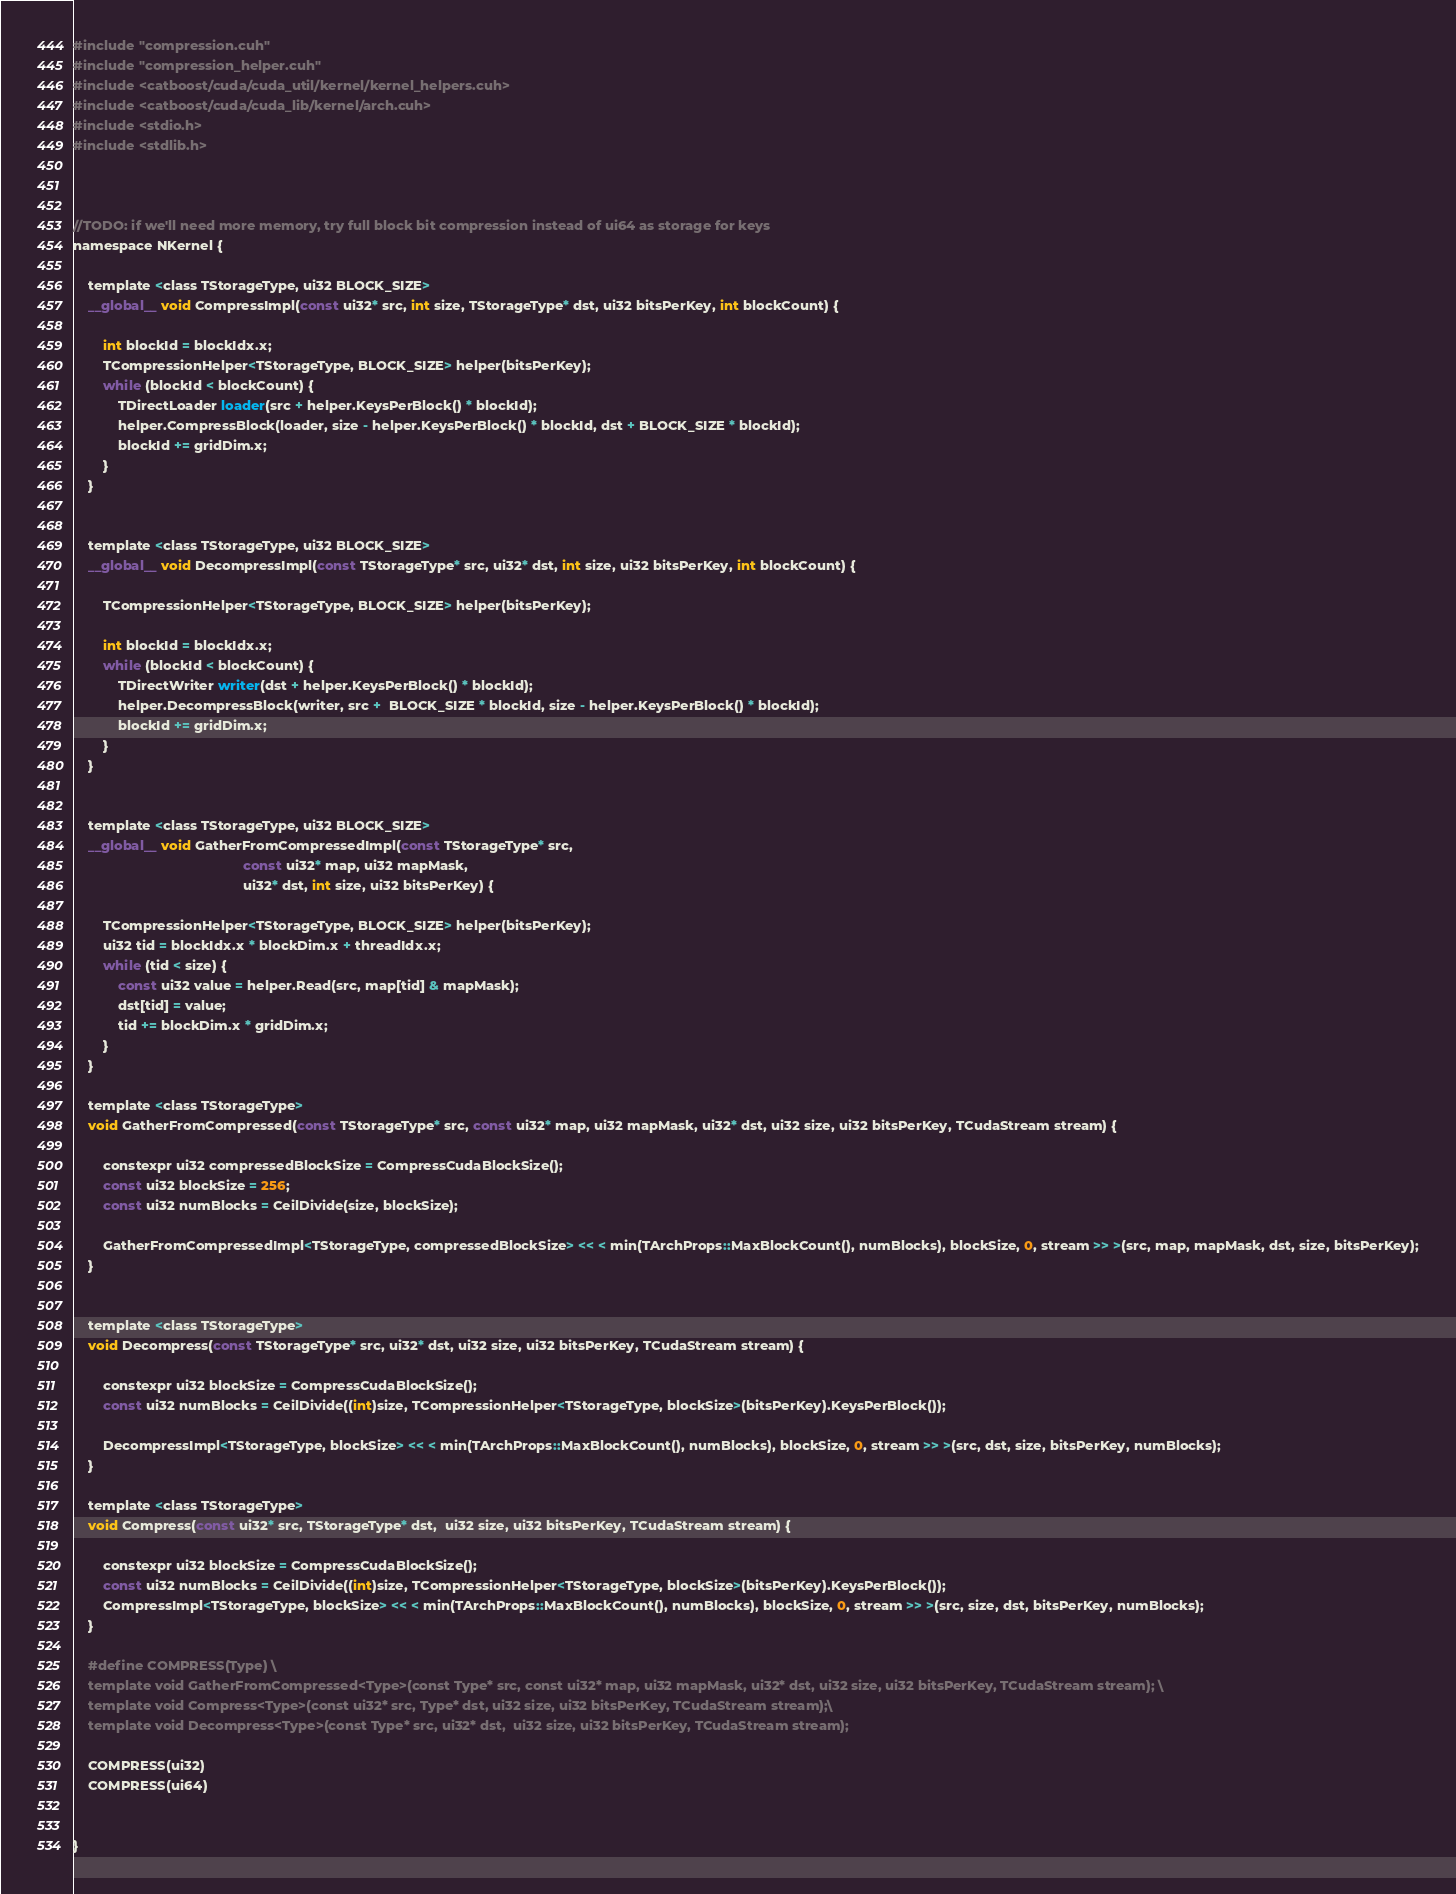Convert code to text. <code><loc_0><loc_0><loc_500><loc_500><_Cuda_>#include "compression.cuh"
#include "compression_helper.cuh"
#include <catboost/cuda/cuda_util/kernel/kernel_helpers.cuh>
#include <catboost/cuda/cuda_lib/kernel/arch.cuh>
#include <stdio.h>
#include <stdlib.h>



//TODO: if we'll need more memory, try full block bit compression instead of ui64 as storage for keys
namespace NKernel {

    template <class TStorageType, ui32 BLOCK_SIZE>
    __global__ void CompressImpl(const ui32* src, int size, TStorageType* dst, ui32 bitsPerKey, int blockCount) {

        int blockId = blockIdx.x;
        TCompressionHelper<TStorageType, BLOCK_SIZE> helper(bitsPerKey);
        while (blockId < blockCount) {
            TDirectLoader loader(src + helper.KeysPerBlock() * blockId);
            helper.CompressBlock(loader, size - helper.KeysPerBlock() * blockId, dst + BLOCK_SIZE * blockId);
            blockId += gridDim.x;
        }
    }


    template <class TStorageType, ui32 BLOCK_SIZE>
    __global__ void DecompressImpl(const TStorageType* src, ui32* dst, int size, ui32 bitsPerKey, int blockCount) {

        TCompressionHelper<TStorageType, BLOCK_SIZE> helper(bitsPerKey);

        int blockId = blockIdx.x;
        while (blockId < blockCount) {
            TDirectWriter writer(dst + helper.KeysPerBlock() * blockId);
            helper.DecompressBlock(writer, src +  BLOCK_SIZE * blockId, size - helper.KeysPerBlock() * blockId);
            blockId += gridDim.x;
        }
    }


    template <class TStorageType, ui32 BLOCK_SIZE>
    __global__ void GatherFromCompressedImpl(const TStorageType* src,
                                             const ui32* map, ui32 mapMask,
                                             ui32* dst, int size, ui32 bitsPerKey) {

        TCompressionHelper<TStorageType, BLOCK_SIZE> helper(bitsPerKey);
        ui32 tid = blockIdx.x * blockDim.x + threadIdx.x;
        while (tid < size) {
            const ui32 value = helper.Read(src, map[tid] & mapMask);
            dst[tid] = value;
            tid += blockDim.x * gridDim.x;
        }
    }

    template <class TStorageType>
    void GatherFromCompressed(const TStorageType* src, const ui32* map, ui32 mapMask, ui32* dst, ui32 size, ui32 bitsPerKey, TCudaStream stream) {

        constexpr ui32 compressedBlockSize = CompressCudaBlockSize();
        const ui32 blockSize = 256;
        const ui32 numBlocks = CeilDivide(size, blockSize);

        GatherFromCompressedImpl<TStorageType, compressedBlockSize> << < min(TArchProps::MaxBlockCount(), numBlocks), blockSize, 0, stream >> >(src, map, mapMask, dst, size, bitsPerKey);
    }


    template <class TStorageType>
    void Decompress(const TStorageType* src, ui32* dst, ui32 size, ui32 bitsPerKey, TCudaStream stream) {

        constexpr ui32 blockSize = CompressCudaBlockSize();
        const ui32 numBlocks = CeilDivide((int)size, TCompressionHelper<TStorageType, blockSize>(bitsPerKey).KeysPerBlock());

        DecompressImpl<TStorageType, blockSize> << < min(TArchProps::MaxBlockCount(), numBlocks), blockSize, 0, stream >> >(src, dst, size, bitsPerKey, numBlocks);
    }

    template <class TStorageType>
    void Compress(const ui32* src, TStorageType* dst,  ui32 size, ui32 bitsPerKey, TCudaStream stream) {

        constexpr ui32 blockSize = CompressCudaBlockSize();
        const ui32 numBlocks = CeilDivide((int)size, TCompressionHelper<TStorageType, blockSize>(bitsPerKey).KeysPerBlock());
        CompressImpl<TStorageType, blockSize> << < min(TArchProps::MaxBlockCount(), numBlocks), blockSize, 0, stream >> >(src, size, dst, bitsPerKey, numBlocks);
    }

    #define COMPRESS(Type) \
    template void GatherFromCompressed<Type>(const Type* src, const ui32* map, ui32 mapMask, ui32* dst, ui32 size, ui32 bitsPerKey, TCudaStream stream); \
    template void Compress<Type>(const ui32* src, Type* dst, ui32 size, ui32 bitsPerKey, TCudaStream stream);\
    template void Decompress<Type>(const Type* src, ui32* dst,  ui32 size, ui32 bitsPerKey, TCudaStream stream);

    COMPRESS(ui32)
    COMPRESS(ui64)


}




</code> 